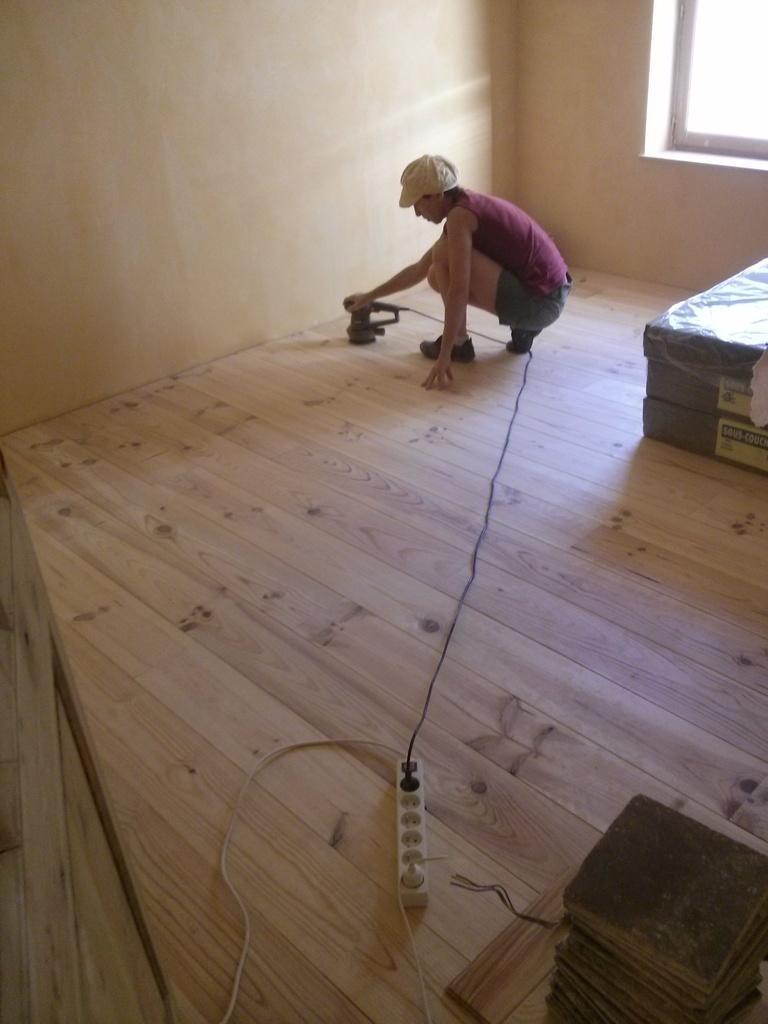Describe this image in one or two sentences. In this image we can see a person wearing pink color T-shirt, green color short, cream colored cap crouching on floor doing some work with machine, on right side of the image there is a bed and in the background of the image there is a wall and window. 